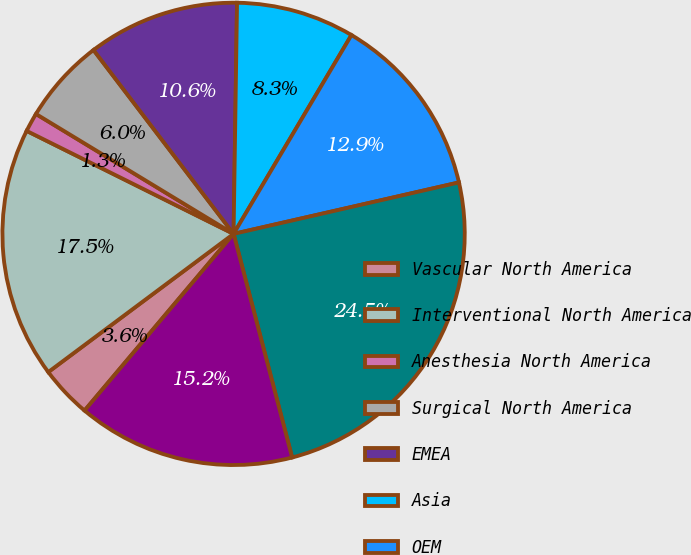<chart> <loc_0><loc_0><loc_500><loc_500><pie_chart><fcel>Vascular North America<fcel>Interventional North America<fcel>Anesthesia North America<fcel>Surgical North America<fcel>EMEA<fcel>Asia<fcel>OEM<fcel>All other<fcel>Segment Net Revenues<nl><fcel>3.65%<fcel>17.55%<fcel>1.33%<fcel>5.96%<fcel>10.6%<fcel>8.28%<fcel>12.91%<fcel>24.5%<fcel>15.23%<nl></chart> 